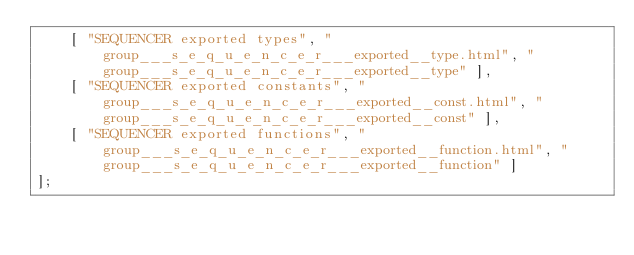Convert code to text. <code><loc_0><loc_0><loc_500><loc_500><_JavaScript_>    [ "SEQUENCER exported types", "group___s_e_q_u_e_n_c_e_r___exported__type.html", "group___s_e_q_u_e_n_c_e_r___exported__type" ],
    [ "SEQUENCER exported constants", "group___s_e_q_u_e_n_c_e_r___exported__const.html", "group___s_e_q_u_e_n_c_e_r___exported__const" ],
    [ "SEQUENCER exported functions", "group___s_e_q_u_e_n_c_e_r___exported__function.html", "group___s_e_q_u_e_n_c_e_r___exported__function" ]
];</code> 